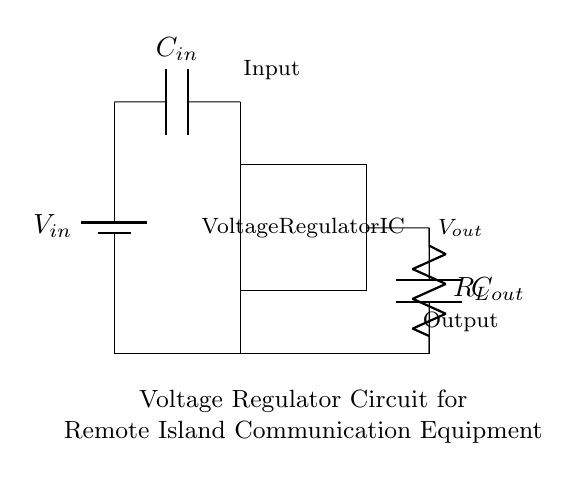What is the input voltage symbol? The input voltage symbol in the diagram is labeled as V_in, indicating the source of power supplied to the circuit.
Answer: V_in What does the rectangle represent in the circuit? The rectangle in the circuit represents the Voltage Regulator IC, which is the main component responsible for regulating the output voltage to ensure stable power supply.
Answer: Voltage Regulator IC What are the components connected in series with the output? The components connected in series with the output include R_L (load resistor) and C_out (output capacitor), which help to manage the load and smoothen the output voltage.
Answer: R_L, C_out What is the purpose of the input capacitor? The input capacitor C_in smoothens the voltage supply to the voltage regulator IC by filtering high-frequency noise and stabilizing the input voltage level.
Answer: Filtering noise How does the voltage regulator affect the output? The voltage regulator stabilizes the output voltage (V_out) by adjusting its internal resistance depending on the load changes, ensuring the output remains consistent even with varying loads.
Answer: Stabilizes output How is the circuit grounded? The circuit is grounded through a connection from the lowest point (0,0) down to the ground line at the bottom of the diagram, ensuring all components have a common return path for current flow.
Answer: Common ground What is the output voltage symbol? The output voltage symbol in the diagram is labeled as V_out, representing the regulated voltage that powers the connected load.
Answer: V_out 